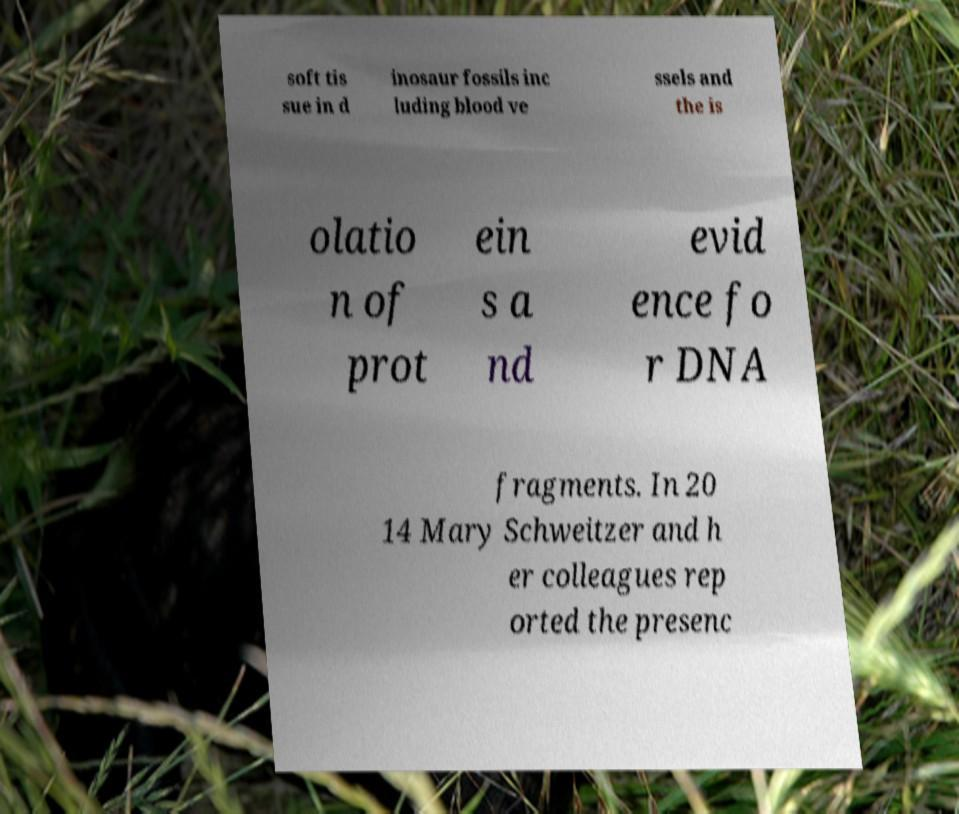Can you read and provide the text displayed in the image?This photo seems to have some interesting text. Can you extract and type it out for me? soft tis sue in d inosaur fossils inc luding blood ve ssels and the is olatio n of prot ein s a nd evid ence fo r DNA fragments. In 20 14 Mary Schweitzer and h er colleagues rep orted the presenc 